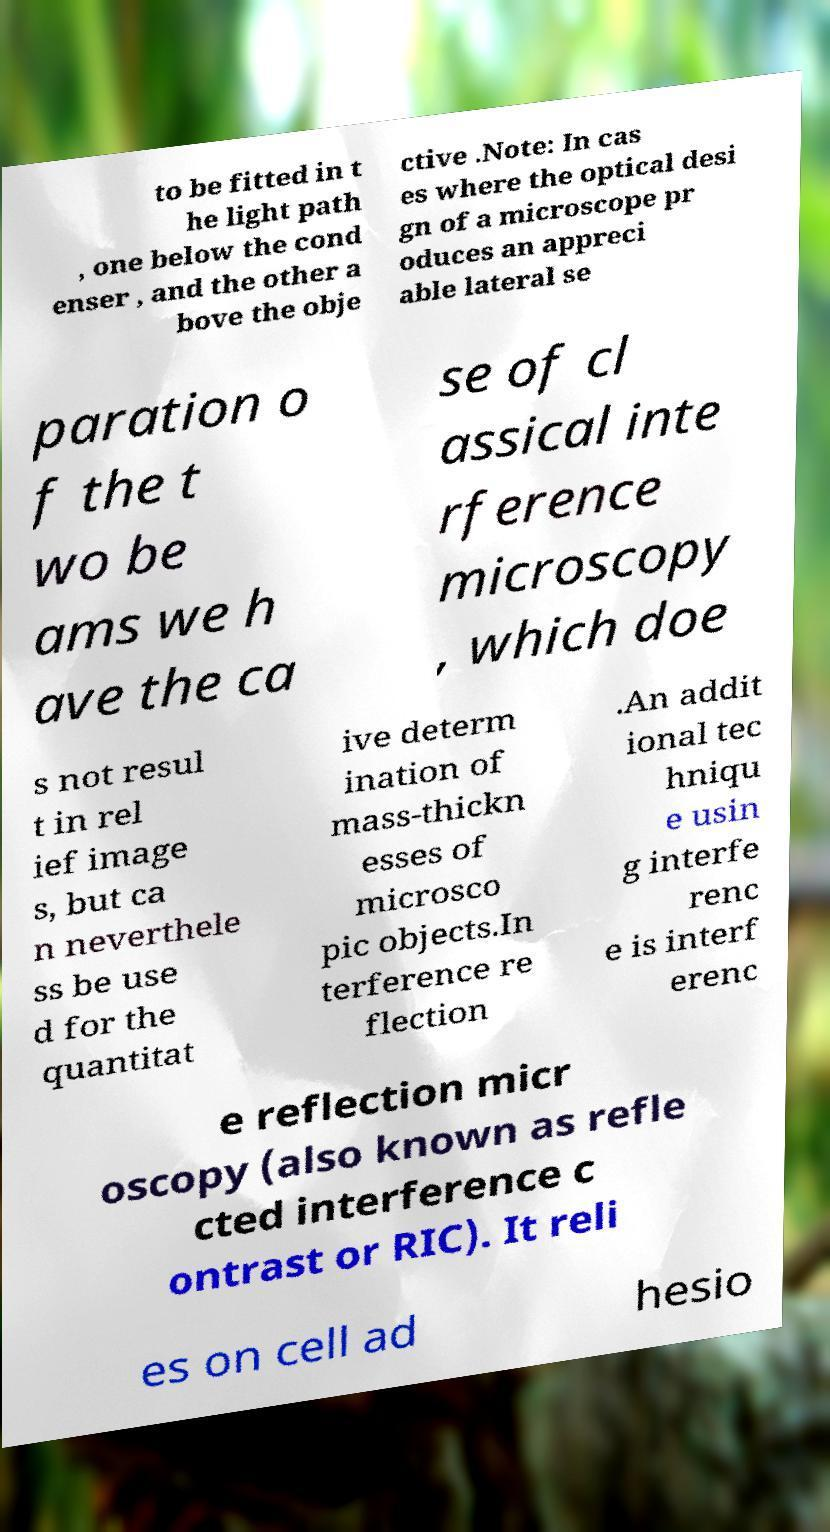For documentation purposes, I need the text within this image transcribed. Could you provide that? to be fitted in t he light path , one below the cond enser , and the other a bove the obje ctive .Note: In cas es where the optical desi gn of a microscope pr oduces an appreci able lateral se paration o f the t wo be ams we h ave the ca se of cl assical inte rference microscopy , which doe s not resul t in rel ief image s, but ca n neverthele ss be use d for the quantitat ive determ ination of mass-thickn esses of microsco pic objects.In terference re flection .An addit ional tec hniqu e usin g interfe renc e is interf erenc e reflection micr oscopy (also known as refle cted interference c ontrast or RIC). It reli es on cell ad hesio 